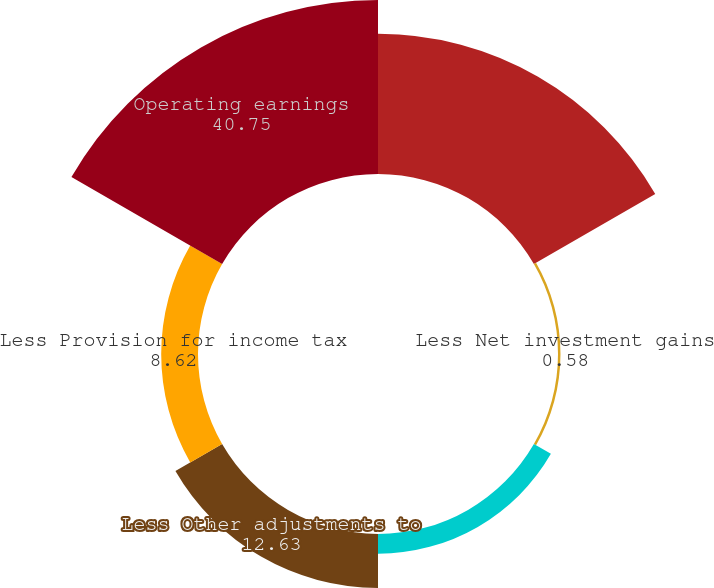Convert chart to OTSL. <chart><loc_0><loc_0><loc_500><loc_500><pie_chart><fcel>Income (loss) from continuing<fcel>Less Net investment gains<fcel>Less Net derivative gains<fcel>Less Other adjustments to<fcel>Less Provision for income tax<fcel>Operating earnings<nl><fcel>32.82%<fcel>0.58%<fcel>4.6%<fcel>12.63%<fcel>8.62%<fcel>40.75%<nl></chart> 